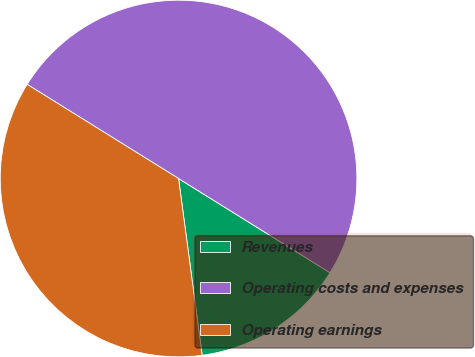<chart> <loc_0><loc_0><loc_500><loc_500><pie_chart><fcel>Revenues<fcel>Operating costs and expenses<fcel>Operating earnings<nl><fcel>14.03%<fcel>50.0%<fcel>35.97%<nl></chart> 